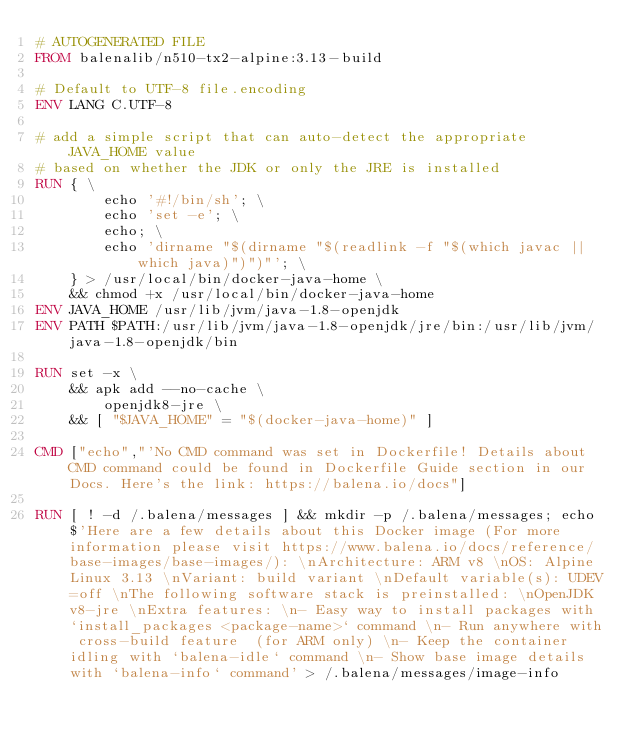<code> <loc_0><loc_0><loc_500><loc_500><_Dockerfile_># AUTOGENERATED FILE
FROM balenalib/n510-tx2-alpine:3.13-build

# Default to UTF-8 file.encoding
ENV LANG C.UTF-8

# add a simple script that can auto-detect the appropriate JAVA_HOME value
# based on whether the JDK or only the JRE is installed
RUN { \
		echo '#!/bin/sh'; \
		echo 'set -e'; \
		echo; \
		echo 'dirname "$(dirname "$(readlink -f "$(which javac || which java)")")"'; \
	} > /usr/local/bin/docker-java-home \
	&& chmod +x /usr/local/bin/docker-java-home
ENV JAVA_HOME /usr/lib/jvm/java-1.8-openjdk
ENV PATH $PATH:/usr/lib/jvm/java-1.8-openjdk/jre/bin:/usr/lib/jvm/java-1.8-openjdk/bin

RUN set -x \
	&& apk add --no-cache \
		openjdk8-jre \
	&& [ "$JAVA_HOME" = "$(docker-java-home)" ]

CMD ["echo","'No CMD command was set in Dockerfile! Details about CMD command could be found in Dockerfile Guide section in our Docs. Here's the link: https://balena.io/docs"]

RUN [ ! -d /.balena/messages ] && mkdir -p /.balena/messages; echo $'Here are a few details about this Docker image (For more information please visit https://www.balena.io/docs/reference/base-images/base-images/): \nArchitecture: ARM v8 \nOS: Alpine Linux 3.13 \nVariant: build variant \nDefault variable(s): UDEV=off \nThe following software stack is preinstalled: \nOpenJDK v8-jre \nExtra features: \n- Easy way to install packages with `install_packages <package-name>` command \n- Run anywhere with cross-build feature  (for ARM only) \n- Keep the container idling with `balena-idle` command \n- Show base image details with `balena-info` command' > /.balena/messages/image-info</code> 